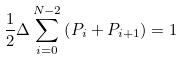Convert formula to latex. <formula><loc_0><loc_0><loc_500><loc_500>\frac { 1 } { 2 } \Delta \sum _ { i = 0 } ^ { N - 2 } \left ( P _ { i } + P _ { i + 1 } \right ) = 1</formula> 